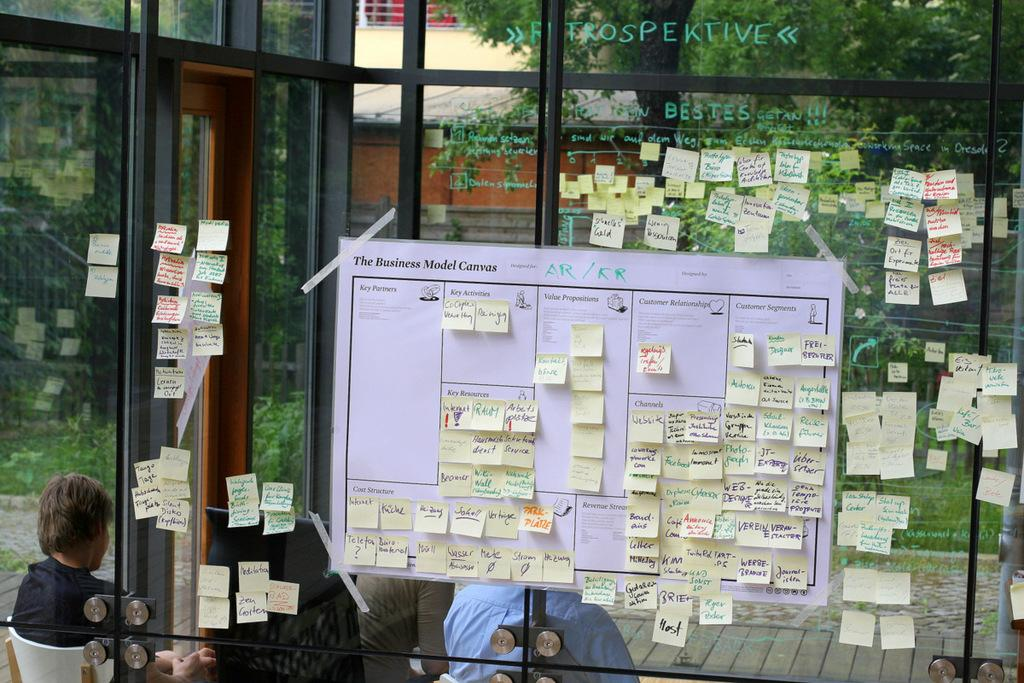What is on the glass in the image? There is a group of papers with text in the image. How are the papers attached to the glass? The papers are pasted on the glass. What can be seen in the background of the image? There is a group of people sitting and a group of trees in the background of the image. What type of light can be seen emanating from the papers in the image? There is no light emanating from the papers in the image; they are simply pasted on the glass with text. 